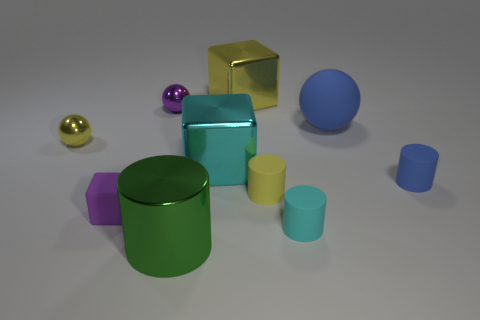Subtract all metal spheres. How many spheres are left? 1 Subtract all red cylinders. Subtract all gray cubes. How many cylinders are left? 4 Subtract 0 gray blocks. How many objects are left? 10 Subtract all blocks. How many objects are left? 7 Subtract all cyan blocks. Subtract all purple balls. How many objects are left? 8 Add 1 big green metal cylinders. How many big green metal cylinders are left? 2 Add 4 metal objects. How many metal objects exist? 9 